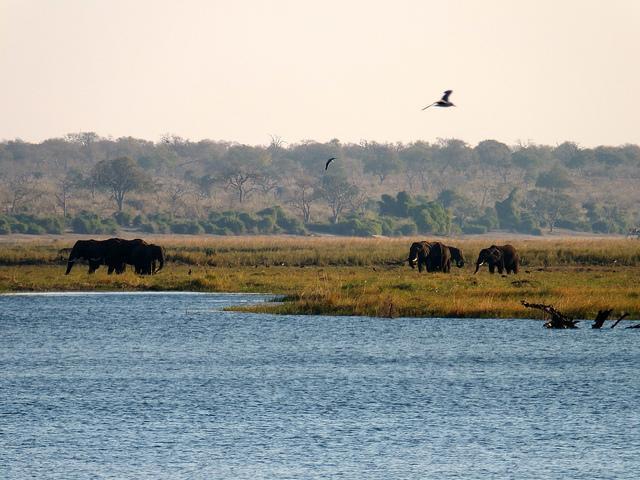Besides Africa what continent can these animals be found naturally on?
Indicate the correct response by choosing from the four available options to answer the question.
Options: South america, asia, europe, australia. Asia. 